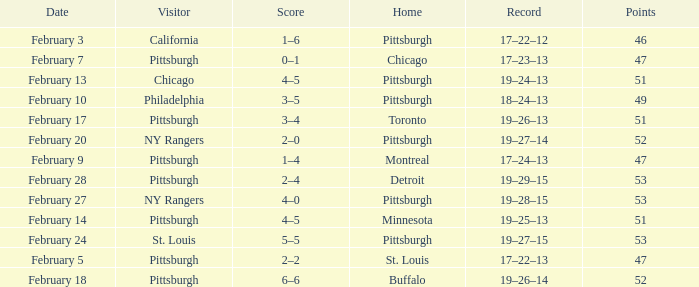Can you parse all the data within this table? {'header': ['Date', 'Visitor', 'Score', 'Home', 'Record', 'Points'], 'rows': [['February 3', 'California', '1–6', 'Pittsburgh', '17–22–12', '46'], ['February 7', 'Pittsburgh', '0–1', 'Chicago', '17–23–13', '47'], ['February 13', 'Chicago', '4–5', 'Pittsburgh', '19–24–13', '51'], ['February 10', 'Philadelphia', '3–5', 'Pittsburgh', '18–24–13', '49'], ['February 17', 'Pittsburgh', '3–4', 'Toronto', '19–26–13', '51'], ['February 20', 'NY Rangers', '2–0', 'Pittsburgh', '19–27–14', '52'], ['February 9', 'Pittsburgh', '1–4', 'Montreal', '17–24–13', '47'], ['February 28', 'Pittsburgh', '2–4', 'Detroit', '19–29–15', '53'], ['February 27', 'NY Rangers', '4–0', 'Pittsburgh', '19–28–15', '53'], ['February 14', 'Pittsburgh', '4–5', 'Minnesota', '19–25–13', '51'], ['February 24', 'St. Louis', '5–5', 'Pittsburgh', '19–27–15', '53'], ['February 5', 'Pittsburgh', '2–2', 'St. Louis', '17–22–13', '47'], ['February 18', 'Pittsburgh', '6–6', 'Buffalo', '19–26–14', '52']]} Which Score has a Visitor of ny rangers, and a Record of 19–28–15? 4–0. 